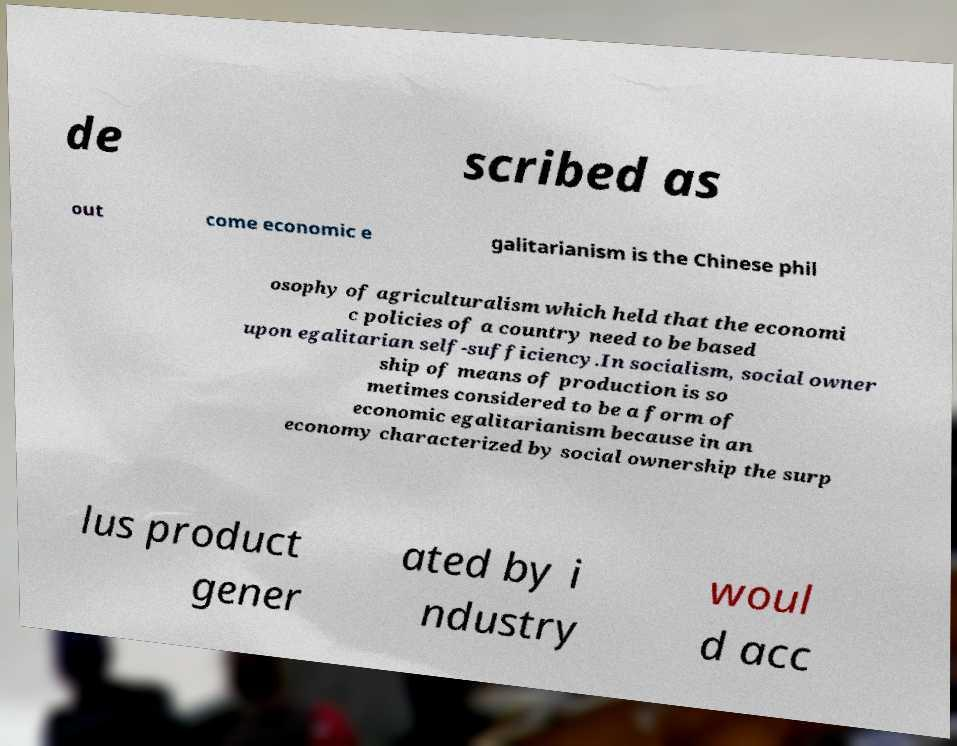Can you read and provide the text displayed in the image?This photo seems to have some interesting text. Can you extract and type it out for me? de scribed as out come economic e galitarianism is the Chinese phil osophy of agriculturalism which held that the economi c policies of a country need to be based upon egalitarian self-sufficiency.In socialism, social owner ship of means of production is so metimes considered to be a form of economic egalitarianism because in an economy characterized by social ownership the surp lus product gener ated by i ndustry woul d acc 